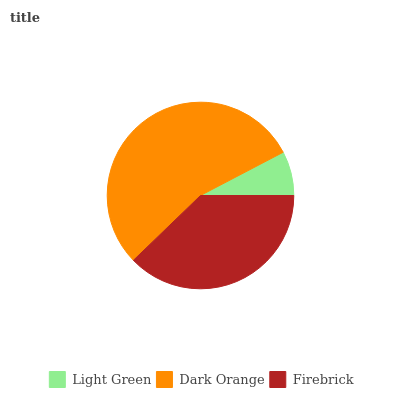Is Light Green the minimum?
Answer yes or no. Yes. Is Dark Orange the maximum?
Answer yes or no. Yes. Is Firebrick the minimum?
Answer yes or no. No. Is Firebrick the maximum?
Answer yes or no. No. Is Dark Orange greater than Firebrick?
Answer yes or no. Yes. Is Firebrick less than Dark Orange?
Answer yes or no. Yes. Is Firebrick greater than Dark Orange?
Answer yes or no. No. Is Dark Orange less than Firebrick?
Answer yes or no. No. Is Firebrick the high median?
Answer yes or no. Yes. Is Firebrick the low median?
Answer yes or no. Yes. Is Light Green the high median?
Answer yes or no. No. Is Light Green the low median?
Answer yes or no. No. 